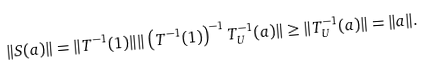<formula> <loc_0><loc_0><loc_500><loc_500>\| S ( a ) \| = \| T ^ { - 1 } ( 1 ) \| \| \left ( T ^ { - 1 } ( 1 ) \right ) ^ { - 1 } T _ { U } ^ { - 1 } ( a ) \| \geq \| T _ { U } ^ { - 1 } ( a ) \| = \| a \| .</formula> 